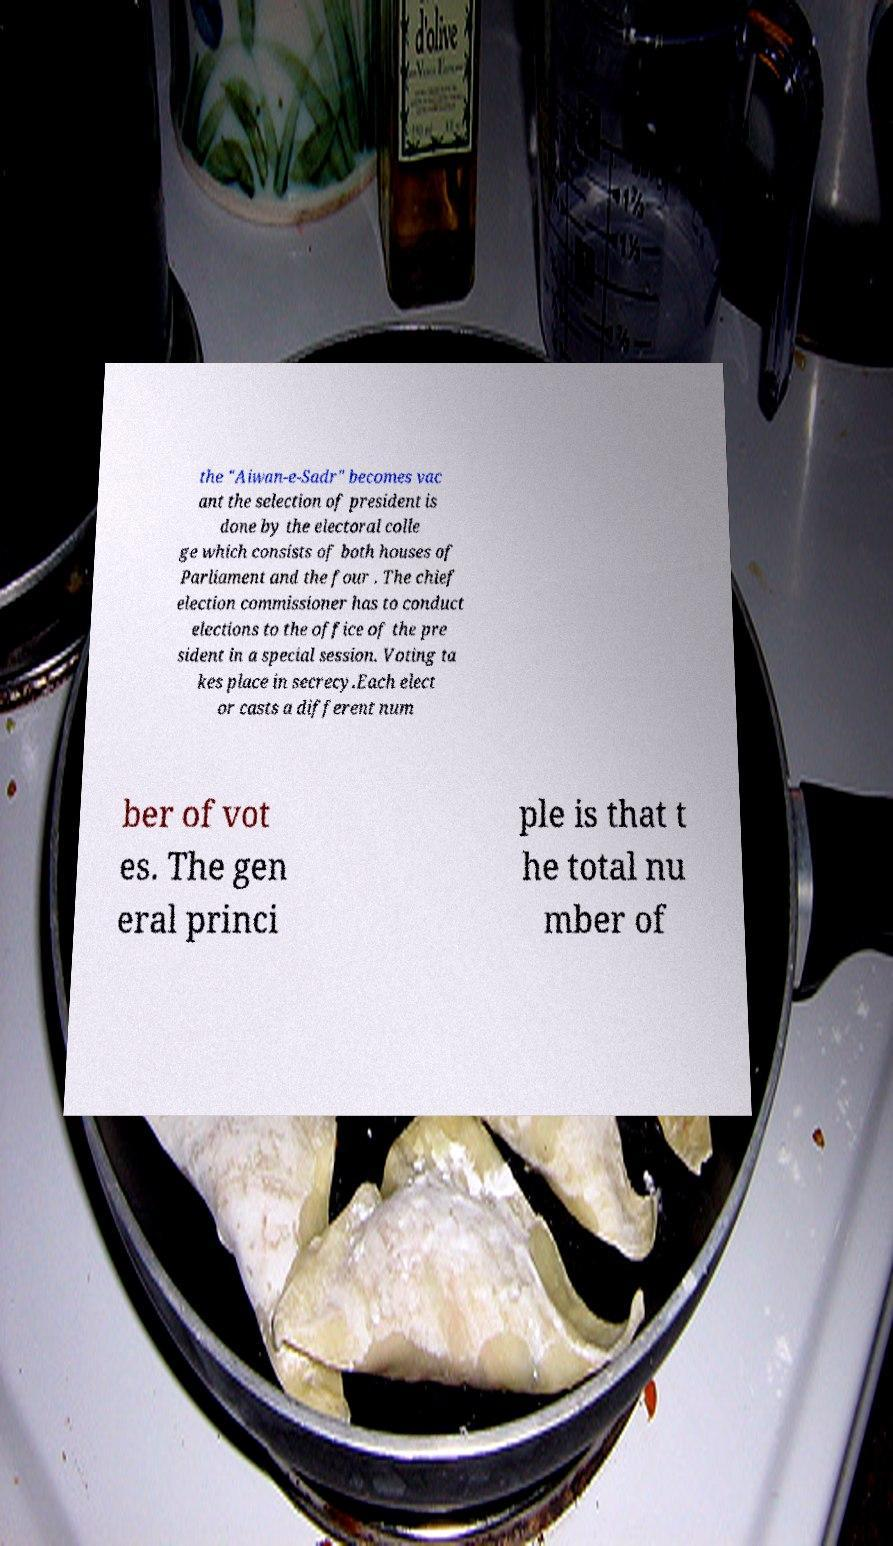Can you accurately transcribe the text from the provided image for me? the "Aiwan-e-Sadr" becomes vac ant the selection of president is done by the electoral colle ge which consists of both houses of Parliament and the four . The chief election commissioner has to conduct elections to the office of the pre sident in a special session. Voting ta kes place in secrecy.Each elect or casts a different num ber of vot es. The gen eral princi ple is that t he total nu mber of 